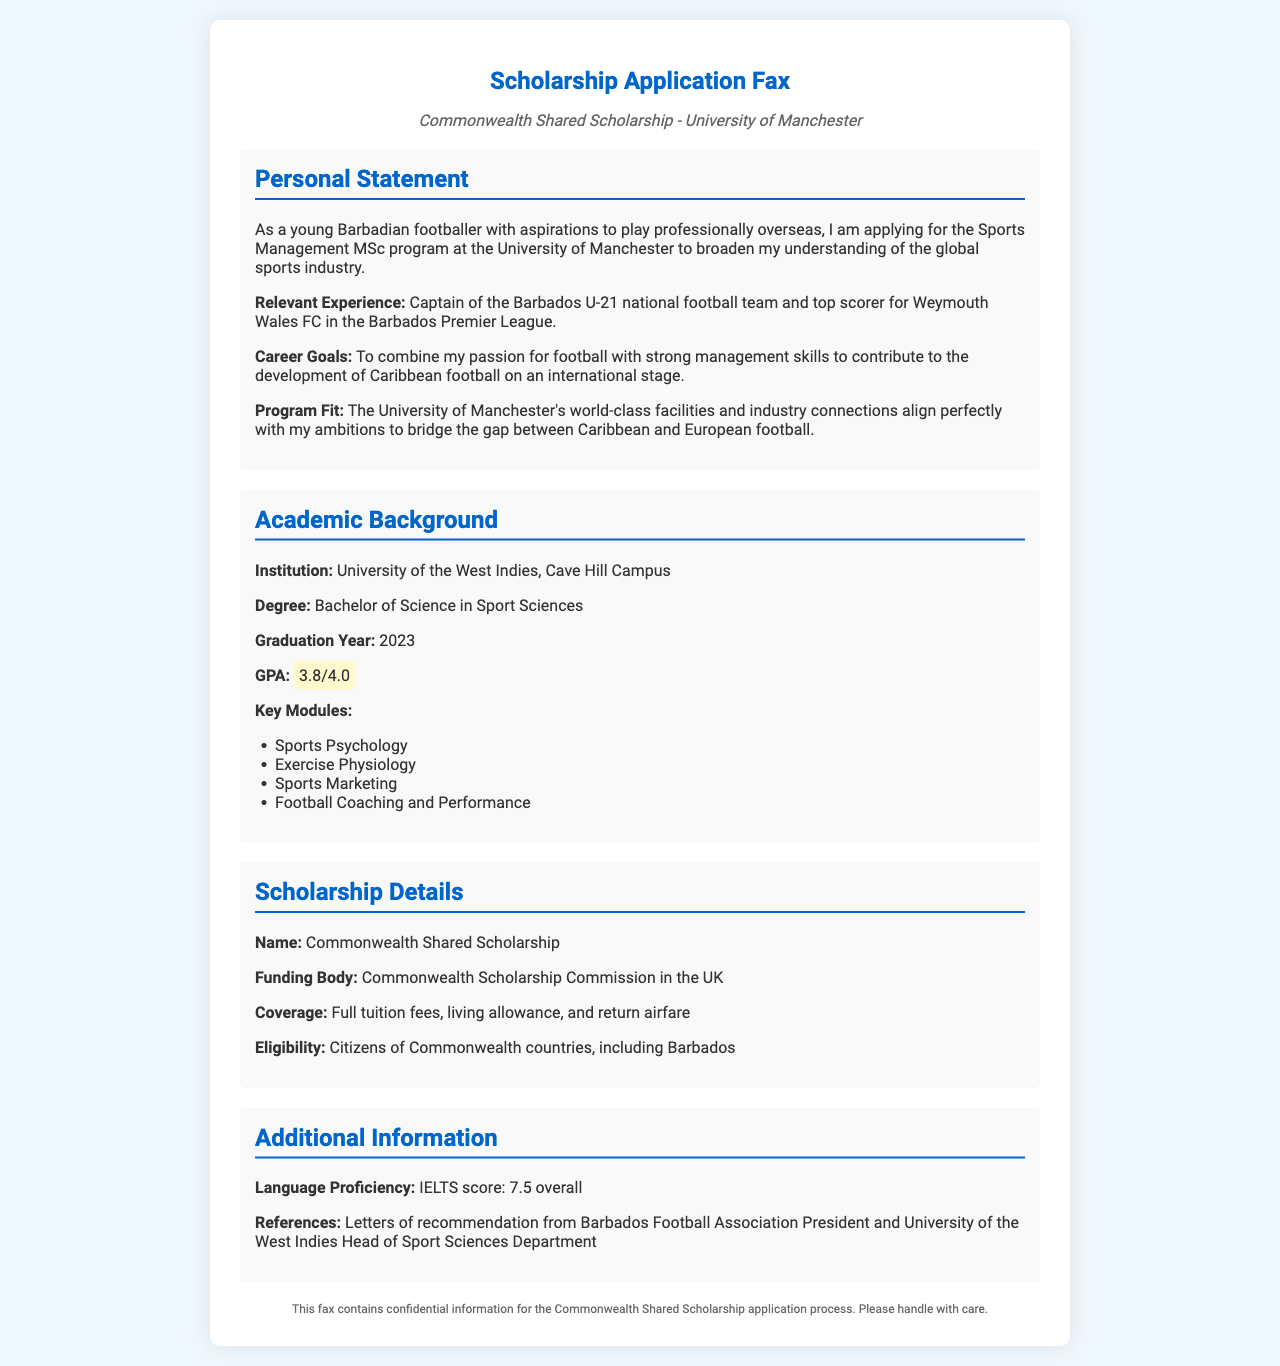What is the degree obtained by the applicant? The document states that the applicant holds a Bachelor of Science in Sport Sciences from the University of the West Indies.
Answer: Bachelor of Science in Sport Sciences What is the GPA of the applicant? The document highlights the applicant's GPA, which is a key academic achievement.
Answer: 3.8/4.0 Who is the scholarship funding body? The document specifies that the funding body for the scholarship is the Commonwealth Scholarship Commission in the UK.
Answer: Commonwealth Scholarship Commission in the UK What is the IELTS score of the applicant? The document includes the applicant's language proficiency, specifically their IELTS score.
Answer: 7.5 overall What are the key modules studied by the applicant? The document lists several key modules in the applicant's academic background, and this question asks for specific examples.
Answer: Sports Psychology, Exercise Physiology, Sports Marketing, Football Coaching and Performance What does the scholarship cover? The document outlines the coverage details of the scholarship, highlighting what financial support is provided.
Answer: Full tuition fees, living allowance, and return airfare What is the applicant's current position in football? The document mentions the applicant's relevant experience and role within the national team, indicating their leadership status.
Answer: Captain of the Barbados U-21 national football team What are the career goals of the applicant? The document outlines the applicant's aspirations in the context of their education and football career.
Answer: To combine my passion for football with strong management skills What is the name of the scholarship? The document clearly names the scholarship being applied for, which is important for understanding the applicant's focus.
Answer: Commonwealth Shared Scholarship 